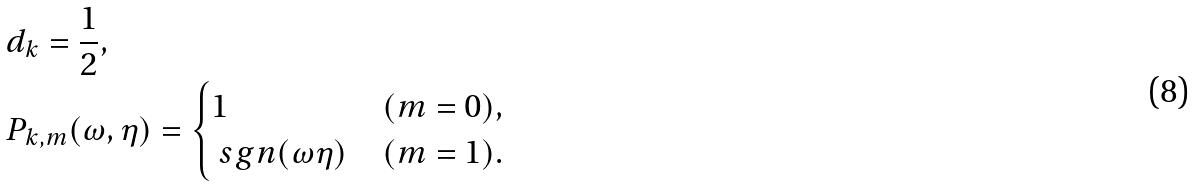Convert formula to latex. <formula><loc_0><loc_0><loc_500><loc_500>& d _ { k } = \frac { 1 } { 2 } , \\ & P _ { k , m } ( \omega , \eta ) = \begin{cases} 1 & ( m = 0 ) , \\ \ s g n ( \omega \eta ) & ( m = 1 ) . \end{cases}</formula> 